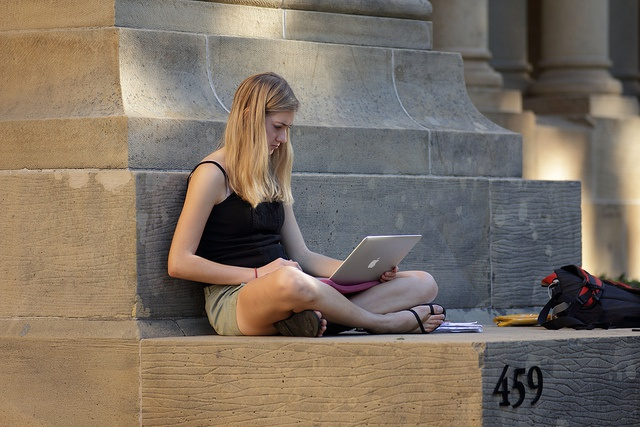Describe the objects in this image and their specific colors. I can see people in tan, black, gray, and darkgray tones, backpack in tan, black, gray, and maroon tones, and laptop in tan, gray, black, and darkgray tones in this image. 